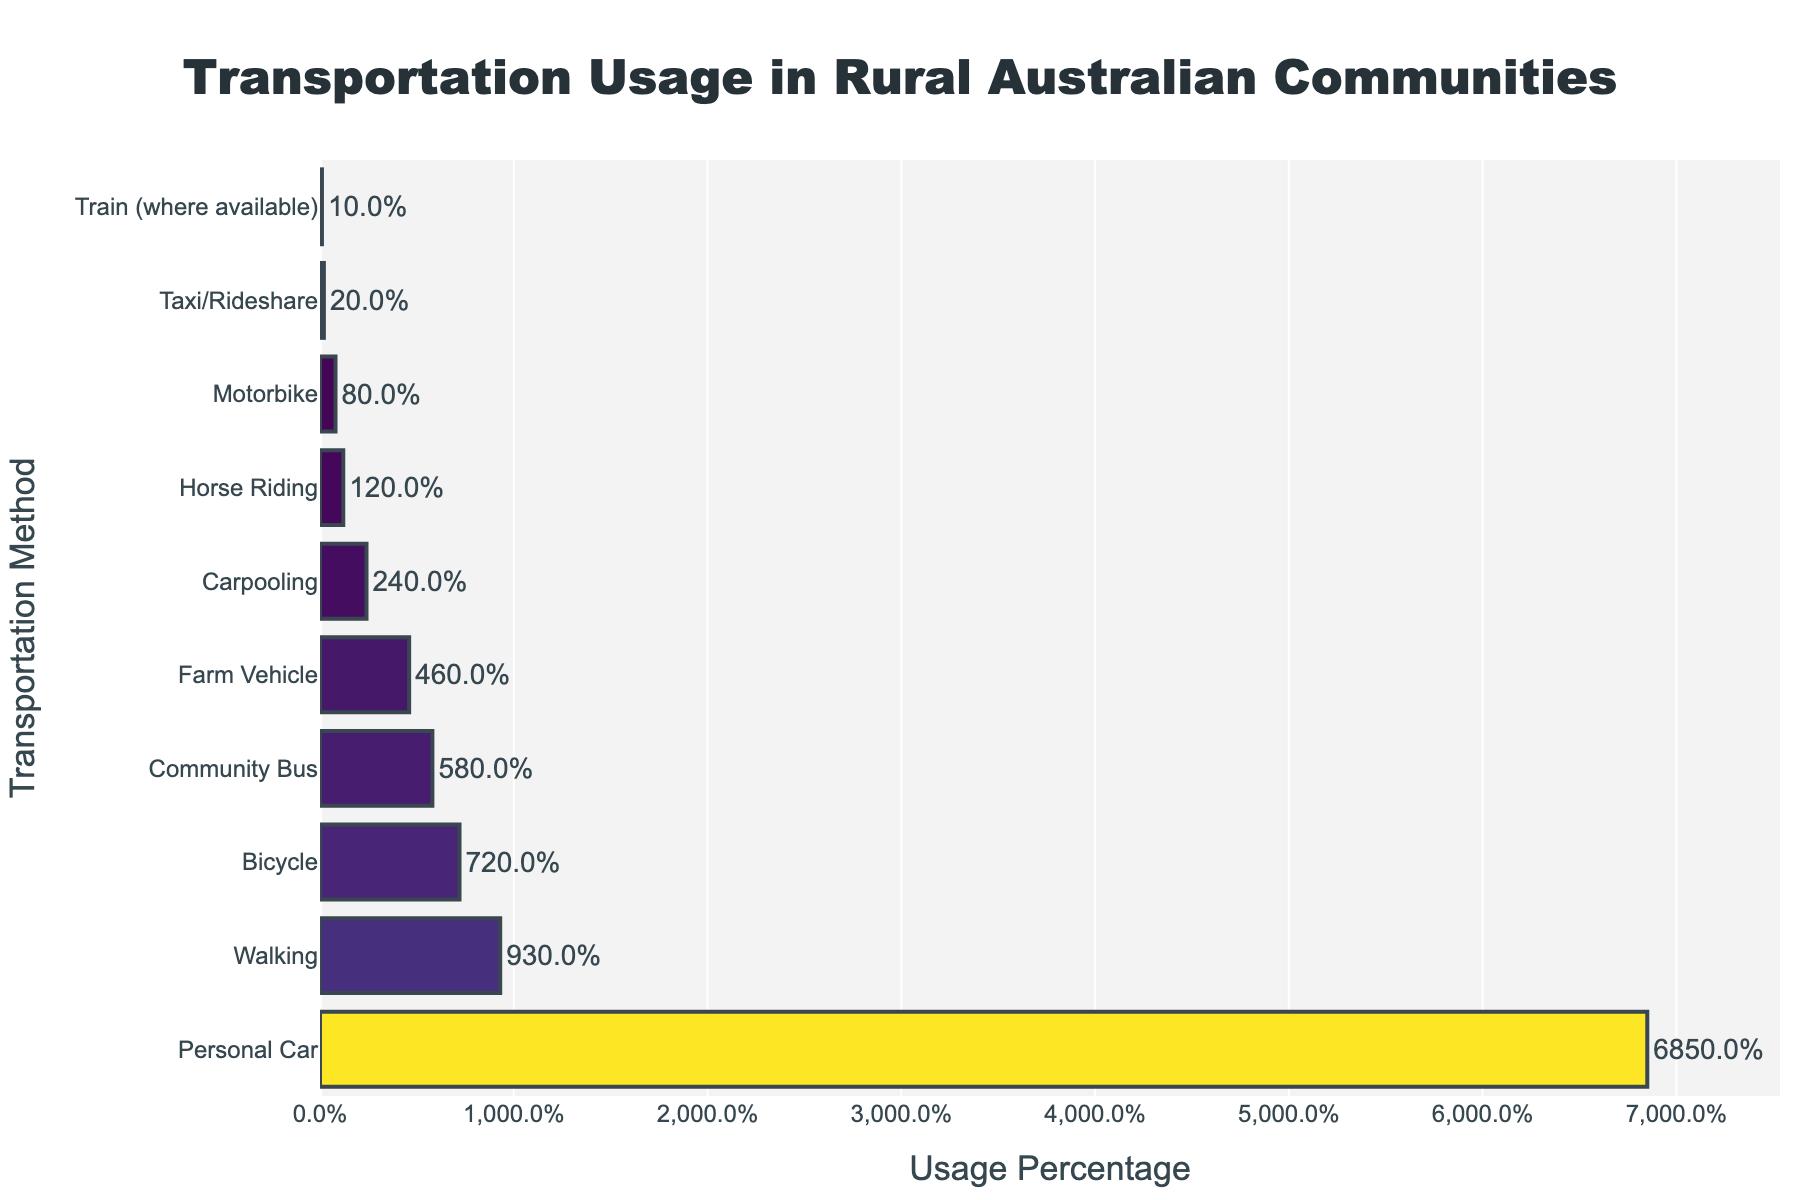What is the most commonly used transportation method in rural Australian communities? The figure shows the transportation methods on the y-axis and their usage percentages on the x-axis. By looking at the bar that extends the farthest to the right, we see that 'Personal Car' has the highest usage percentage.
Answer: Personal Car Which transportation method is used the least by rural Australian communities? To find the least used method, look for the bar that extends the least to the right. 'Train (where available)' has the smallest bar, indicating it is the least used method.
Answer: Train (where available) How much more popular is using a personal car compared to walking? The percentage for 'Personal Car' is 68.5% and for 'Walking' is 9.3%. Subtract the walking percentage from the car percentage: 68.5% - 9.3% = 59.2%.
Answer: 59.2% Which transportation methods have usage percentages lower than community bus? The 'Community Bus' has a usage percentage of 5.8%. Methods with lower percentages are 'Farm Vehicle' (4.6%), 'Horse Riding' (1.2%), 'Carpooling' (2.4%), 'Motorbike' (0.8%), 'Taxi/Rideshare' (0.2%), and 'Train (where available)' (0.1%).
Answer: Farm Vehicle, Horse Riding, Carpooling, Motorbike, Taxi/Rideshare, Train (where available) If you combine the usage percentages of bicycle and walking, do they surpass the usage of personal cars? Bicycle usage is 7.2% and walking usage is 9.3%. Adding these together: 7.2% + 9.3% = 16.5%. This combined value is less than the personal car usage of 68.5%.
Answer: No Which has a higher usage percentage, carpooling or motorbike? By comparing the lengths of the bars, 'Carpooling' (2.4%) has a higher usage percentage than 'Motorbike' (0.8%).
Answer: Carpooling Are there any methods with usage percentages between 5% and 10%? Yes, by locating the bars that fall within this range. 'Bicycle' has a usage of 7.2% and 'Walking' has a usage of 9.3%, both within the 5%-10% range.
Answer: Bicycle, Walking What is the total usage percentage for all other methods excluding personal car? Summing the percentages of all other methods: 7.2% + 9.3% + 5.8% + 4.6% + 1.2% + 2.4% + 0.8% + 0.2% + 0.1% = 31.6%.
Answer: 31.6% How does the usage of farm vehicles compare to motorbikes? The usage percentage for 'Farm Vehicle' is 4.6%, while 'Motorbike' is 0.8%. Farm vehicles have a higher usage percentage.
Answer: Farm Vehicle Considering the three least used transportation methods, what is their combined usage percentage? The least used methods are 'Motorbike' (0.8%), 'Taxi/Rideshare' (0.2%), and 'Train (where available)' (0.1%). Adding these percentages: 0.8% + 0.2% + 0.1% = 1.1%.
Answer: 1.1% 